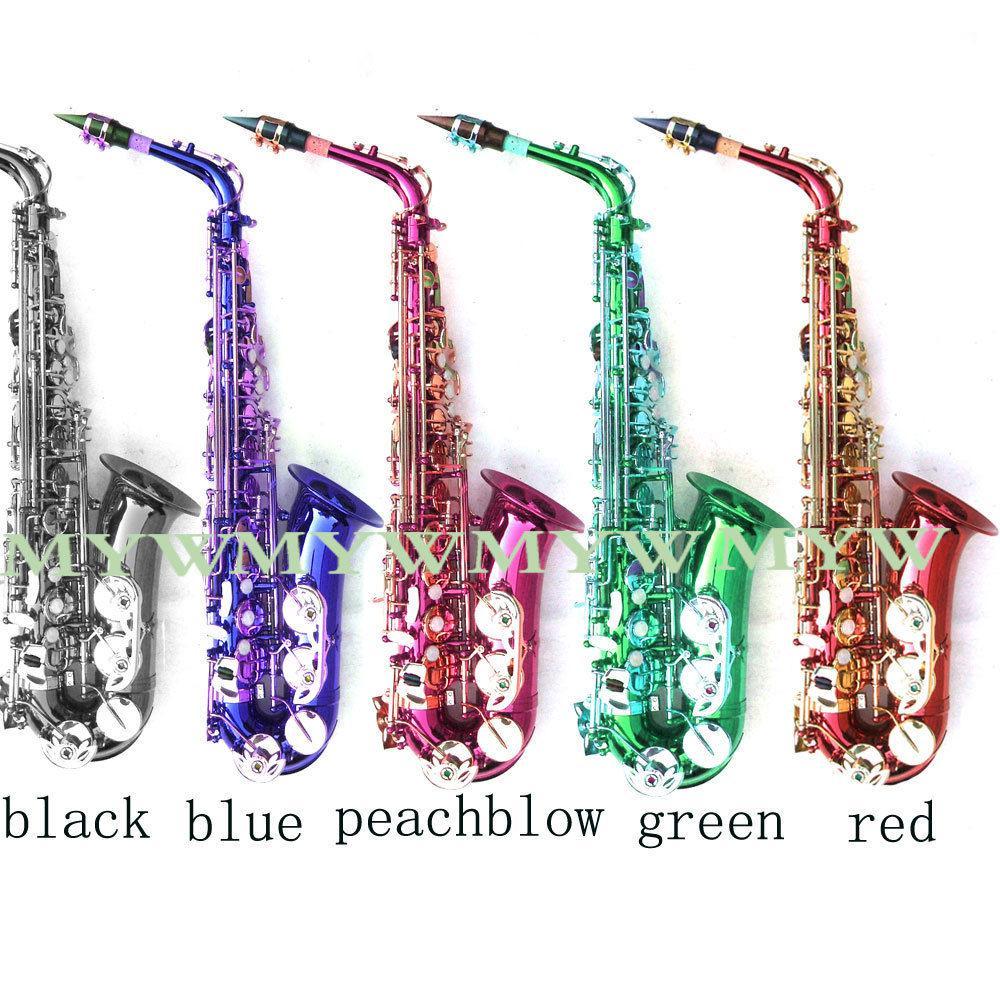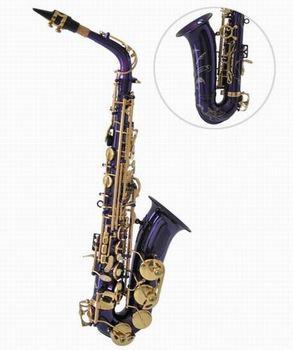The first image is the image on the left, the second image is the image on the right. Given the left and right images, does the statement "An image shows just one view of one bright blue saxophone with brass-colored buttons." hold true? Answer yes or no. No. The first image is the image on the left, the second image is the image on the right. Assess this claim about the two images: "There are more instruments shown in the image on the left.". Correct or not? Answer yes or no. Yes. 